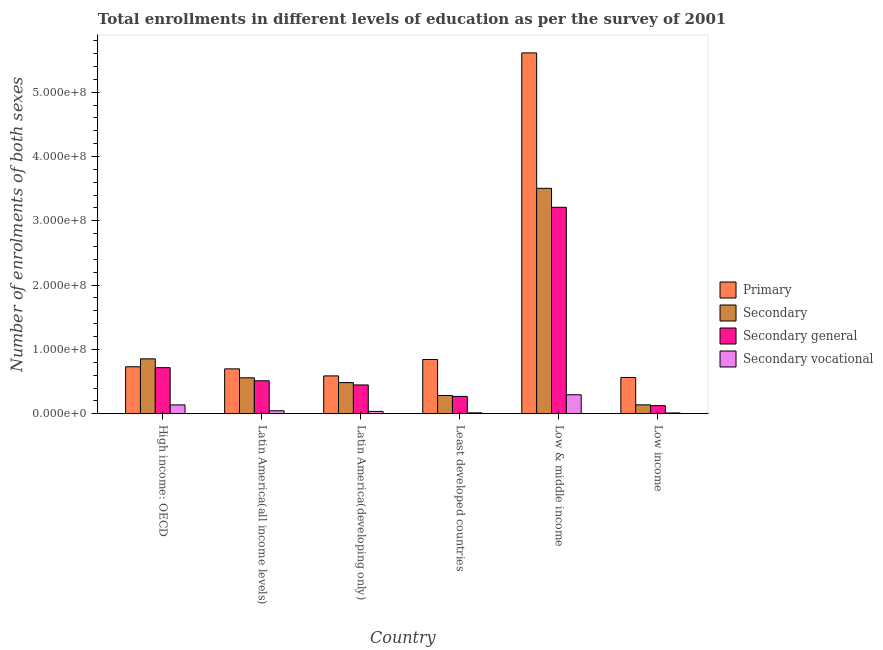How many different coloured bars are there?
Give a very brief answer. 4. How many bars are there on the 3rd tick from the left?
Your answer should be very brief. 4. What is the label of the 1st group of bars from the left?
Your answer should be compact. High income: OECD. What is the number of enrolments in secondary general education in High income: OECD?
Keep it short and to the point. 7.16e+07. Across all countries, what is the maximum number of enrolments in secondary general education?
Your response must be concise. 3.21e+08. Across all countries, what is the minimum number of enrolments in secondary general education?
Your answer should be very brief. 1.26e+07. In which country was the number of enrolments in secondary vocational education maximum?
Your response must be concise. Low & middle income. What is the total number of enrolments in secondary general education in the graph?
Offer a terse response. 5.28e+08. What is the difference between the number of enrolments in primary education in High income: OECD and that in Least developed countries?
Provide a short and direct response. -1.13e+07. What is the difference between the number of enrolments in secondary education in Latin America(developing only) and the number of enrolments in primary education in Least developed countries?
Your answer should be compact. -3.60e+07. What is the average number of enrolments in secondary general education per country?
Provide a succinct answer. 8.80e+07. What is the difference between the number of enrolments in secondary vocational education and number of enrolments in secondary education in Least developed countries?
Ensure brevity in your answer.  -2.69e+07. What is the ratio of the number of enrolments in secondary education in Latin America(all income levels) to that in Least developed countries?
Your answer should be very brief. 1.97. Is the number of enrolments in secondary education in High income: OECD less than that in Low income?
Give a very brief answer. No. What is the difference between the highest and the second highest number of enrolments in primary education?
Your answer should be very brief. 4.77e+08. What is the difference between the highest and the lowest number of enrolments in secondary vocational education?
Give a very brief answer. 2.83e+07. In how many countries, is the number of enrolments in primary education greater than the average number of enrolments in primary education taken over all countries?
Offer a very short reply. 1. Is the sum of the number of enrolments in secondary vocational education in Latin America(developing only) and Least developed countries greater than the maximum number of enrolments in secondary general education across all countries?
Make the answer very short. No. What does the 1st bar from the left in Least developed countries represents?
Give a very brief answer. Primary. What does the 3rd bar from the right in High income: OECD represents?
Offer a very short reply. Secondary. Are all the bars in the graph horizontal?
Your answer should be very brief. No. What is the difference between two consecutive major ticks on the Y-axis?
Your answer should be compact. 1.00e+08. Are the values on the major ticks of Y-axis written in scientific E-notation?
Give a very brief answer. Yes. Does the graph contain any zero values?
Offer a terse response. No. Does the graph contain grids?
Your response must be concise. No. How many legend labels are there?
Provide a succinct answer. 4. How are the legend labels stacked?
Ensure brevity in your answer.  Vertical. What is the title of the graph?
Make the answer very short. Total enrollments in different levels of education as per the survey of 2001. Does "Forest" appear as one of the legend labels in the graph?
Provide a succinct answer. No. What is the label or title of the X-axis?
Your answer should be compact. Country. What is the label or title of the Y-axis?
Provide a succinct answer. Number of enrolments of both sexes. What is the Number of enrolments of both sexes of Primary in High income: OECD?
Make the answer very short. 7.30e+07. What is the Number of enrolments of both sexes in Secondary in High income: OECD?
Offer a very short reply. 8.54e+07. What is the Number of enrolments of both sexes of Secondary general in High income: OECD?
Your answer should be compact. 7.16e+07. What is the Number of enrolments of both sexes of Secondary vocational in High income: OECD?
Your answer should be compact. 1.37e+07. What is the Number of enrolments of both sexes of Primary in Latin America(all income levels)?
Keep it short and to the point. 6.98e+07. What is the Number of enrolments of both sexes of Secondary in Latin America(all income levels)?
Offer a very short reply. 5.59e+07. What is the Number of enrolments of both sexes of Secondary general in Latin America(all income levels)?
Provide a short and direct response. 5.12e+07. What is the Number of enrolments of both sexes of Secondary vocational in Latin America(all income levels)?
Keep it short and to the point. 4.64e+06. What is the Number of enrolments of both sexes of Primary in Latin America(developing only)?
Offer a very short reply. 5.88e+07. What is the Number of enrolments of both sexes of Secondary in Latin America(developing only)?
Provide a succinct answer. 4.84e+07. What is the Number of enrolments of both sexes in Secondary general in Latin America(developing only)?
Your response must be concise. 4.48e+07. What is the Number of enrolments of both sexes in Secondary vocational in Latin America(developing only)?
Make the answer very short. 3.64e+06. What is the Number of enrolments of both sexes of Primary in Least developed countries?
Offer a very short reply. 8.44e+07. What is the Number of enrolments of both sexes of Secondary in Least developed countries?
Your answer should be compact. 2.83e+07. What is the Number of enrolments of both sexes of Secondary general in Least developed countries?
Make the answer very short. 2.69e+07. What is the Number of enrolments of both sexes in Secondary vocational in Least developed countries?
Provide a short and direct response. 1.39e+06. What is the Number of enrolments of both sexes of Primary in Low & middle income?
Make the answer very short. 5.61e+08. What is the Number of enrolments of both sexes of Secondary in Low & middle income?
Ensure brevity in your answer.  3.50e+08. What is the Number of enrolments of both sexes of Secondary general in Low & middle income?
Offer a terse response. 3.21e+08. What is the Number of enrolments of both sexes in Secondary vocational in Low & middle income?
Keep it short and to the point. 2.95e+07. What is the Number of enrolments of both sexes of Primary in Low income?
Give a very brief answer. 5.64e+07. What is the Number of enrolments of both sexes of Secondary in Low income?
Your answer should be very brief. 1.38e+07. What is the Number of enrolments of both sexes in Secondary general in Low income?
Provide a succinct answer. 1.26e+07. What is the Number of enrolments of both sexes of Secondary vocational in Low income?
Your answer should be compact. 1.23e+06. Across all countries, what is the maximum Number of enrolments of both sexes in Primary?
Your response must be concise. 5.61e+08. Across all countries, what is the maximum Number of enrolments of both sexes of Secondary?
Ensure brevity in your answer.  3.50e+08. Across all countries, what is the maximum Number of enrolments of both sexes of Secondary general?
Your answer should be very brief. 3.21e+08. Across all countries, what is the maximum Number of enrolments of both sexes in Secondary vocational?
Offer a terse response. 2.95e+07. Across all countries, what is the minimum Number of enrolments of both sexes in Primary?
Your response must be concise. 5.64e+07. Across all countries, what is the minimum Number of enrolments of both sexes of Secondary?
Offer a terse response. 1.38e+07. Across all countries, what is the minimum Number of enrolments of both sexes in Secondary general?
Provide a succinct answer. 1.26e+07. Across all countries, what is the minimum Number of enrolments of both sexes in Secondary vocational?
Your answer should be very brief. 1.23e+06. What is the total Number of enrolments of both sexes in Primary in the graph?
Provide a short and direct response. 9.03e+08. What is the total Number of enrolments of both sexes in Secondary in the graph?
Your response must be concise. 5.82e+08. What is the total Number of enrolments of both sexes of Secondary general in the graph?
Your answer should be very brief. 5.28e+08. What is the total Number of enrolments of both sexes in Secondary vocational in the graph?
Offer a terse response. 5.42e+07. What is the difference between the Number of enrolments of both sexes of Primary in High income: OECD and that in Latin America(all income levels)?
Your answer should be compact. 3.26e+06. What is the difference between the Number of enrolments of both sexes in Secondary in High income: OECD and that in Latin America(all income levels)?
Your answer should be very brief. 2.95e+07. What is the difference between the Number of enrolments of both sexes of Secondary general in High income: OECD and that in Latin America(all income levels)?
Give a very brief answer. 2.04e+07. What is the difference between the Number of enrolments of both sexes in Secondary vocational in High income: OECD and that in Latin America(all income levels)?
Provide a succinct answer. 9.10e+06. What is the difference between the Number of enrolments of both sexes in Primary in High income: OECD and that in Latin America(developing only)?
Keep it short and to the point. 1.42e+07. What is the difference between the Number of enrolments of both sexes of Secondary in High income: OECD and that in Latin America(developing only)?
Keep it short and to the point. 3.69e+07. What is the difference between the Number of enrolments of both sexes in Secondary general in High income: OECD and that in Latin America(developing only)?
Keep it short and to the point. 2.69e+07. What is the difference between the Number of enrolments of both sexes in Secondary vocational in High income: OECD and that in Latin America(developing only)?
Provide a short and direct response. 1.01e+07. What is the difference between the Number of enrolments of both sexes in Primary in High income: OECD and that in Least developed countries?
Your answer should be compact. -1.13e+07. What is the difference between the Number of enrolments of both sexes of Secondary in High income: OECD and that in Least developed countries?
Your answer should be compact. 5.70e+07. What is the difference between the Number of enrolments of both sexes in Secondary general in High income: OECD and that in Least developed countries?
Provide a succinct answer. 4.47e+07. What is the difference between the Number of enrolments of both sexes of Secondary vocational in High income: OECD and that in Least developed countries?
Give a very brief answer. 1.23e+07. What is the difference between the Number of enrolments of both sexes in Primary in High income: OECD and that in Low & middle income?
Your answer should be very brief. -4.88e+08. What is the difference between the Number of enrolments of both sexes of Secondary in High income: OECD and that in Low & middle income?
Ensure brevity in your answer.  -2.65e+08. What is the difference between the Number of enrolments of both sexes in Secondary general in High income: OECD and that in Low & middle income?
Your answer should be compact. -2.49e+08. What is the difference between the Number of enrolments of both sexes in Secondary vocational in High income: OECD and that in Low & middle income?
Provide a short and direct response. -1.58e+07. What is the difference between the Number of enrolments of both sexes in Primary in High income: OECD and that in Low income?
Your answer should be compact. 1.67e+07. What is the difference between the Number of enrolments of both sexes of Secondary in High income: OECD and that in Low income?
Keep it short and to the point. 7.15e+07. What is the difference between the Number of enrolments of both sexes of Secondary general in High income: OECD and that in Low income?
Make the answer very short. 5.90e+07. What is the difference between the Number of enrolments of both sexes in Secondary vocational in High income: OECD and that in Low income?
Give a very brief answer. 1.25e+07. What is the difference between the Number of enrolments of both sexes of Primary in Latin America(all income levels) and that in Latin America(developing only)?
Offer a terse response. 1.09e+07. What is the difference between the Number of enrolments of both sexes of Secondary in Latin America(all income levels) and that in Latin America(developing only)?
Make the answer very short. 7.45e+06. What is the difference between the Number of enrolments of both sexes of Secondary general in Latin America(all income levels) and that in Latin America(developing only)?
Provide a succinct answer. 6.46e+06. What is the difference between the Number of enrolments of both sexes in Secondary vocational in Latin America(all income levels) and that in Latin America(developing only)?
Your answer should be compact. 9.93e+05. What is the difference between the Number of enrolments of both sexes of Primary in Latin America(all income levels) and that in Least developed countries?
Your answer should be compact. -1.46e+07. What is the difference between the Number of enrolments of both sexes in Secondary in Latin America(all income levels) and that in Least developed countries?
Your answer should be compact. 2.75e+07. What is the difference between the Number of enrolments of both sexes in Secondary general in Latin America(all income levels) and that in Least developed countries?
Give a very brief answer. 2.43e+07. What is the difference between the Number of enrolments of both sexes of Secondary vocational in Latin America(all income levels) and that in Least developed countries?
Provide a short and direct response. 3.24e+06. What is the difference between the Number of enrolments of both sexes in Primary in Latin America(all income levels) and that in Low & middle income?
Give a very brief answer. -4.91e+08. What is the difference between the Number of enrolments of both sexes of Secondary in Latin America(all income levels) and that in Low & middle income?
Keep it short and to the point. -2.95e+08. What is the difference between the Number of enrolments of both sexes of Secondary general in Latin America(all income levels) and that in Low & middle income?
Make the answer very short. -2.70e+08. What is the difference between the Number of enrolments of both sexes in Secondary vocational in Latin America(all income levels) and that in Low & middle income?
Make the answer very short. -2.49e+07. What is the difference between the Number of enrolments of both sexes in Primary in Latin America(all income levels) and that in Low income?
Offer a terse response. 1.34e+07. What is the difference between the Number of enrolments of both sexes of Secondary in Latin America(all income levels) and that in Low income?
Provide a succinct answer. 4.20e+07. What is the difference between the Number of enrolments of both sexes in Secondary general in Latin America(all income levels) and that in Low income?
Offer a terse response. 3.86e+07. What is the difference between the Number of enrolments of both sexes of Secondary vocational in Latin America(all income levels) and that in Low income?
Provide a short and direct response. 3.40e+06. What is the difference between the Number of enrolments of both sexes in Primary in Latin America(developing only) and that in Least developed countries?
Your response must be concise. -2.55e+07. What is the difference between the Number of enrolments of both sexes in Secondary in Latin America(developing only) and that in Least developed countries?
Ensure brevity in your answer.  2.01e+07. What is the difference between the Number of enrolments of both sexes in Secondary general in Latin America(developing only) and that in Least developed countries?
Ensure brevity in your answer.  1.78e+07. What is the difference between the Number of enrolments of both sexes in Secondary vocational in Latin America(developing only) and that in Least developed countries?
Ensure brevity in your answer.  2.25e+06. What is the difference between the Number of enrolments of both sexes of Primary in Latin America(developing only) and that in Low & middle income?
Offer a terse response. -5.02e+08. What is the difference between the Number of enrolments of both sexes of Secondary in Latin America(developing only) and that in Low & middle income?
Ensure brevity in your answer.  -3.02e+08. What is the difference between the Number of enrolments of both sexes in Secondary general in Latin America(developing only) and that in Low & middle income?
Offer a terse response. -2.76e+08. What is the difference between the Number of enrolments of both sexes in Secondary vocational in Latin America(developing only) and that in Low & middle income?
Provide a succinct answer. -2.59e+07. What is the difference between the Number of enrolments of both sexes of Primary in Latin America(developing only) and that in Low income?
Your response must be concise. 2.46e+06. What is the difference between the Number of enrolments of both sexes in Secondary in Latin America(developing only) and that in Low income?
Provide a short and direct response. 3.46e+07. What is the difference between the Number of enrolments of both sexes of Secondary general in Latin America(developing only) and that in Low income?
Your response must be concise. 3.22e+07. What is the difference between the Number of enrolments of both sexes in Secondary vocational in Latin America(developing only) and that in Low income?
Your response must be concise. 2.41e+06. What is the difference between the Number of enrolments of both sexes of Primary in Least developed countries and that in Low & middle income?
Provide a succinct answer. -4.77e+08. What is the difference between the Number of enrolments of both sexes in Secondary in Least developed countries and that in Low & middle income?
Your answer should be very brief. -3.22e+08. What is the difference between the Number of enrolments of both sexes in Secondary general in Least developed countries and that in Low & middle income?
Offer a terse response. -2.94e+08. What is the difference between the Number of enrolments of both sexes of Secondary vocational in Least developed countries and that in Low & middle income?
Your answer should be compact. -2.81e+07. What is the difference between the Number of enrolments of both sexes in Primary in Least developed countries and that in Low income?
Your answer should be compact. 2.80e+07. What is the difference between the Number of enrolments of both sexes in Secondary in Least developed countries and that in Low income?
Offer a very short reply. 1.45e+07. What is the difference between the Number of enrolments of both sexes in Secondary general in Least developed countries and that in Low income?
Offer a very short reply. 1.44e+07. What is the difference between the Number of enrolments of both sexes of Secondary vocational in Least developed countries and that in Low income?
Keep it short and to the point. 1.60e+05. What is the difference between the Number of enrolments of both sexes of Primary in Low & middle income and that in Low income?
Provide a short and direct response. 5.05e+08. What is the difference between the Number of enrolments of both sexes in Secondary in Low & middle income and that in Low income?
Make the answer very short. 3.37e+08. What is the difference between the Number of enrolments of both sexes in Secondary general in Low & middle income and that in Low income?
Your answer should be very brief. 3.08e+08. What is the difference between the Number of enrolments of both sexes in Secondary vocational in Low & middle income and that in Low income?
Provide a succinct answer. 2.83e+07. What is the difference between the Number of enrolments of both sexes of Primary in High income: OECD and the Number of enrolments of both sexes of Secondary in Latin America(all income levels)?
Give a very brief answer. 1.72e+07. What is the difference between the Number of enrolments of both sexes of Primary in High income: OECD and the Number of enrolments of both sexes of Secondary general in Latin America(all income levels)?
Keep it short and to the point. 2.18e+07. What is the difference between the Number of enrolments of both sexes in Primary in High income: OECD and the Number of enrolments of both sexes in Secondary vocational in Latin America(all income levels)?
Your answer should be very brief. 6.84e+07. What is the difference between the Number of enrolments of both sexes of Secondary in High income: OECD and the Number of enrolments of both sexes of Secondary general in Latin America(all income levels)?
Give a very brief answer. 3.41e+07. What is the difference between the Number of enrolments of both sexes of Secondary in High income: OECD and the Number of enrolments of both sexes of Secondary vocational in Latin America(all income levels)?
Give a very brief answer. 8.07e+07. What is the difference between the Number of enrolments of both sexes in Secondary general in High income: OECD and the Number of enrolments of both sexes in Secondary vocational in Latin America(all income levels)?
Your answer should be compact. 6.70e+07. What is the difference between the Number of enrolments of both sexes of Primary in High income: OECD and the Number of enrolments of both sexes of Secondary in Latin America(developing only)?
Give a very brief answer. 2.46e+07. What is the difference between the Number of enrolments of both sexes in Primary in High income: OECD and the Number of enrolments of both sexes in Secondary general in Latin America(developing only)?
Keep it short and to the point. 2.83e+07. What is the difference between the Number of enrolments of both sexes in Primary in High income: OECD and the Number of enrolments of both sexes in Secondary vocational in Latin America(developing only)?
Offer a very short reply. 6.94e+07. What is the difference between the Number of enrolments of both sexes of Secondary in High income: OECD and the Number of enrolments of both sexes of Secondary general in Latin America(developing only)?
Keep it short and to the point. 4.06e+07. What is the difference between the Number of enrolments of both sexes in Secondary in High income: OECD and the Number of enrolments of both sexes in Secondary vocational in Latin America(developing only)?
Provide a short and direct response. 8.17e+07. What is the difference between the Number of enrolments of both sexes of Secondary general in High income: OECD and the Number of enrolments of both sexes of Secondary vocational in Latin America(developing only)?
Offer a terse response. 6.80e+07. What is the difference between the Number of enrolments of both sexes in Primary in High income: OECD and the Number of enrolments of both sexes in Secondary in Least developed countries?
Your answer should be compact. 4.47e+07. What is the difference between the Number of enrolments of both sexes of Primary in High income: OECD and the Number of enrolments of both sexes of Secondary general in Least developed countries?
Provide a succinct answer. 4.61e+07. What is the difference between the Number of enrolments of both sexes in Primary in High income: OECD and the Number of enrolments of both sexes in Secondary vocational in Least developed countries?
Offer a very short reply. 7.16e+07. What is the difference between the Number of enrolments of both sexes in Secondary in High income: OECD and the Number of enrolments of both sexes in Secondary general in Least developed countries?
Offer a very short reply. 5.84e+07. What is the difference between the Number of enrolments of both sexes of Secondary in High income: OECD and the Number of enrolments of both sexes of Secondary vocational in Least developed countries?
Give a very brief answer. 8.40e+07. What is the difference between the Number of enrolments of both sexes in Secondary general in High income: OECD and the Number of enrolments of both sexes in Secondary vocational in Least developed countries?
Provide a succinct answer. 7.02e+07. What is the difference between the Number of enrolments of both sexes of Primary in High income: OECD and the Number of enrolments of both sexes of Secondary in Low & middle income?
Your response must be concise. -2.77e+08. What is the difference between the Number of enrolments of both sexes in Primary in High income: OECD and the Number of enrolments of both sexes in Secondary general in Low & middle income?
Your answer should be compact. -2.48e+08. What is the difference between the Number of enrolments of both sexes in Primary in High income: OECD and the Number of enrolments of both sexes in Secondary vocational in Low & middle income?
Give a very brief answer. 4.35e+07. What is the difference between the Number of enrolments of both sexes in Secondary in High income: OECD and the Number of enrolments of both sexes in Secondary general in Low & middle income?
Offer a very short reply. -2.36e+08. What is the difference between the Number of enrolments of both sexes of Secondary in High income: OECD and the Number of enrolments of both sexes of Secondary vocational in Low & middle income?
Your answer should be compact. 5.58e+07. What is the difference between the Number of enrolments of both sexes in Secondary general in High income: OECD and the Number of enrolments of both sexes in Secondary vocational in Low & middle income?
Provide a succinct answer. 4.21e+07. What is the difference between the Number of enrolments of both sexes in Primary in High income: OECD and the Number of enrolments of both sexes in Secondary in Low income?
Your answer should be very brief. 5.92e+07. What is the difference between the Number of enrolments of both sexes in Primary in High income: OECD and the Number of enrolments of both sexes in Secondary general in Low income?
Your response must be concise. 6.04e+07. What is the difference between the Number of enrolments of both sexes of Primary in High income: OECD and the Number of enrolments of both sexes of Secondary vocational in Low income?
Offer a terse response. 7.18e+07. What is the difference between the Number of enrolments of both sexes of Secondary in High income: OECD and the Number of enrolments of both sexes of Secondary general in Low income?
Keep it short and to the point. 7.28e+07. What is the difference between the Number of enrolments of both sexes in Secondary in High income: OECD and the Number of enrolments of both sexes in Secondary vocational in Low income?
Keep it short and to the point. 8.41e+07. What is the difference between the Number of enrolments of both sexes of Secondary general in High income: OECD and the Number of enrolments of both sexes of Secondary vocational in Low income?
Give a very brief answer. 7.04e+07. What is the difference between the Number of enrolments of both sexes in Primary in Latin America(all income levels) and the Number of enrolments of both sexes in Secondary in Latin America(developing only)?
Provide a succinct answer. 2.14e+07. What is the difference between the Number of enrolments of both sexes in Primary in Latin America(all income levels) and the Number of enrolments of both sexes in Secondary general in Latin America(developing only)?
Make the answer very short. 2.50e+07. What is the difference between the Number of enrolments of both sexes in Primary in Latin America(all income levels) and the Number of enrolments of both sexes in Secondary vocational in Latin America(developing only)?
Your answer should be very brief. 6.61e+07. What is the difference between the Number of enrolments of both sexes in Secondary in Latin America(all income levels) and the Number of enrolments of both sexes in Secondary general in Latin America(developing only)?
Ensure brevity in your answer.  1.11e+07. What is the difference between the Number of enrolments of both sexes of Secondary in Latin America(all income levels) and the Number of enrolments of both sexes of Secondary vocational in Latin America(developing only)?
Keep it short and to the point. 5.22e+07. What is the difference between the Number of enrolments of both sexes in Secondary general in Latin America(all income levels) and the Number of enrolments of both sexes in Secondary vocational in Latin America(developing only)?
Your answer should be very brief. 4.76e+07. What is the difference between the Number of enrolments of both sexes in Primary in Latin America(all income levels) and the Number of enrolments of both sexes in Secondary in Least developed countries?
Your answer should be compact. 4.14e+07. What is the difference between the Number of enrolments of both sexes in Primary in Latin America(all income levels) and the Number of enrolments of both sexes in Secondary general in Least developed countries?
Ensure brevity in your answer.  4.28e+07. What is the difference between the Number of enrolments of both sexes of Primary in Latin America(all income levels) and the Number of enrolments of both sexes of Secondary vocational in Least developed countries?
Provide a succinct answer. 6.84e+07. What is the difference between the Number of enrolments of both sexes of Secondary in Latin America(all income levels) and the Number of enrolments of both sexes of Secondary general in Least developed countries?
Your response must be concise. 2.89e+07. What is the difference between the Number of enrolments of both sexes in Secondary in Latin America(all income levels) and the Number of enrolments of both sexes in Secondary vocational in Least developed countries?
Your answer should be very brief. 5.45e+07. What is the difference between the Number of enrolments of both sexes of Secondary general in Latin America(all income levels) and the Number of enrolments of both sexes of Secondary vocational in Least developed countries?
Offer a terse response. 4.98e+07. What is the difference between the Number of enrolments of both sexes in Primary in Latin America(all income levels) and the Number of enrolments of both sexes in Secondary in Low & middle income?
Your response must be concise. -2.81e+08. What is the difference between the Number of enrolments of both sexes of Primary in Latin America(all income levels) and the Number of enrolments of both sexes of Secondary general in Low & middle income?
Offer a very short reply. -2.51e+08. What is the difference between the Number of enrolments of both sexes in Primary in Latin America(all income levels) and the Number of enrolments of both sexes in Secondary vocational in Low & middle income?
Ensure brevity in your answer.  4.02e+07. What is the difference between the Number of enrolments of both sexes in Secondary in Latin America(all income levels) and the Number of enrolments of both sexes in Secondary general in Low & middle income?
Your answer should be very brief. -2.65e+08. What is the difference between the Number of enrolments of both sexes in Secondary in Latin America(all income levels) and the Number of enrolments of both sexes in Secondary vocational in Low & middle income?
Your answer should be very brief. 2.63e+07. What is the difference between the Number of enrolments of both sexes in Secondary general in Latin America(all income levels) and the Number of enrolments of both sexes in Secondary vocational in Low & middle income?
Make the answer very short. 2.17e+07. What is the difference between the Number of enrolments of both sexes of Primary in Latin America(all income levels) and the Number of enrolments of both sexes of Secondary in Low income?
Offer a terse response. 5.59e+07. What is the difference between the Number of enrolments of both sexes of Primary in Latin America(all income levels) and the Number of enrolments of both sexes of Secondary general in Low income?
Your answer should be compact. 5.72e+07. What is the difference between the Number of enrolments of both sexes in Primary in Latin America(all income levels) and the Number of enrolments of both sexes in Secondary vocational in Low income?
Offer a terse response. 6.85e+07. What is the difference between the Number of enrolments of both sexes of Secondary in Latin America(all income levels) and the Number of enrolments of both sexes of Secondary general in Low income?
Your answer should be compact. 4.33e+07. What is the difference between the Number of enrolments of both sexes in Secondary in Latin America(all income levels) and the Number of enrolments of both sexes in Secondary vocational in Low income?
Your answer should be compact. 5.46e+07. What is the difference between the Number of enrolments of both sexes of Secondary general in Latin America(all income levels) and the Number of enrolments of both sexes of Secondary vocational in Low income?
Keep it short and to the point. 5.00e+07. What is the difference between the Number of enrolments of both sexes in Primary in Latin America(developing only) and the Number of enrolments of both sexes in Secondary in Least developed countries?
Ensure brevity in your answer.  3.05e+07. What is the difference between the Number of enrolments of both sexes in Primary in Latin America(developing only) and the Number of enrolments of both sexes in Secondary general in Least developed countries?
Make the answer very short. 3.19e+07. What is the difference between the Number of enrolments of both sexes in Primary in Latin America(developing only) and the Number of enrolments of both sexes in Secondary vocational in Least developed countries?
Your answer should be very brief. 5.74e+07. What is the difference between the Number of enrolments of both sexes of Secondary in Latin America(developing only) and the Number of enrolments of both sexes of Secondary general in Least developed countries?
Ensure brevity in your answer.  2.15e+07. What is the difference between the Number of enrolments of both sexes in Secondary in Latin America(developing only) and the Number of enrolments of both sexes in Secondary vocational in Least developed countries?
Offer a terse response. 4.70e+07. What is the difference between the Number of enrolments of both sexes in Secondary general in Latin America(developing only) and the Number of enrolments of both sexes in Secondary vocational in Least developed countries?
Offer a very short reply. 4.34e+07. What is the difference between the Number of enrolments of both sexes of Primary in Latin America(developing only) and the Number of enrolments of both sexes of Secondary in Low & middle income?
Your response must be concise. -2.92e+08. What is the difference between the Number of enrolments of both sexes in Primary in Latin America(developing only) and the Number of enrolments of both sexes in Secondary general in Low & middle income?
Your answer should be very brief. -2.62e+08. What is the difference between the Number of enrolments of both sexes of Primary in Latin America(developing only) and the Number of enrolments of both sexes of Secondary vocational in Low & middle income?
Your response must be concise. 2.93e+07. What is the difference between the Number of enrolments of both sexes of Secondary in Latin America(developing only) and the Number of enrolments of both sexes of Secondary general in Low & middle income?
Make the answer very short. -2.73e+08. What is the difference between the Number of enrolments of both sexes in Secondary in Latin America(developing only) and the Number of enrolments of both sexes in Secondary vocational in Low & middle income?
Ensure brevity in your answer.  1.89e+07. What is the difference between the Number of enrolments of both sexes in Secondary general in Latin America(developing only) and the Number of enrolments of both sexes in Secondary vocational in Low & middle income?
Provide a succinct answer. 1.52e+07. What is the difference between the Number of enrolments of both sexes in Primary in Latin America(developing only) and the Number of enrolments of both sexes in Secondary in Low income?
Offer a terse response. 4.50e+07. What is the difference between the Number of enrolments of both sexes of Primary in Latin America(developing only) and the Number of enrolments of both sexes of Secondary general in Low income?
Offer a terse response. 4.62e+07. What is the difference between the Number of enrolments of both sexes in Primary in Latin America(developing only) and the Number of enrolments of both sexes in Secondary vocational in Low income?
Provide a short and direct response. 5.76e+07. What is the difference between the Number of enrolments of both sexes in Secondary in Latin America(developing only) and the Number of enrolments of both sexes in Secondary general in Low income?
Make the answer very short. 3.58e+07. What is the difference between the Number of enrolments of both sexes in Secondary in Latin America(developing only) and the Number of enrolments of both sexes in Secondary vocational in Low income?
Keep it short and to the point. 4.72e+07. What is the difference between the Number of enrolments of both sexes in Secondary general in Latin America(developing only) and the Number of enrolments of both sexes in Secondary vocational in Low income?
Your answer should be compact. 4.35e+07. What is the difference between the Number of enrolments of both sexes in Primary in Least developed countries and the Number of enrolments of both sexes in Secondary in Low & middle income?
Make the answer very short. -2.66e+08. What is the difference between the Number of enrolments of both sexes of Primary in Least developed countries and the Number of enrolments of both sexes of Secondary general in Low & middle income?
Keep it short and to the point. -2.37e+08. What is the difference between the Number of enrolments of both sexes in Primary in Least developed countries and the Number of enrolments of both sexes in Secondary vocational in Low & middle income?
Make the answer very short. 5.48e+07. What is the difference between the Number of enrolments of both sexes of Secondary in Least developed countries and the Number of enrolments of both sexes of Secondary general in Low & middle income?
Your response must be concise. -2.93e+08. What is the difference between the Number of enrolments of both sexes of Secondary in Least developed countries and the Number of enrolments of both sexes of Secondary vocational in Low & middle income?
Make the answer very short. -1.18e+06. What is the difference between the Number of enrolments of both sexes of Secondary general in Least developed countries and the Number of enrolments of both sexes of Secondary vocational in Low & middle income?
Your answer should be compact. -2.57e+06. What is the difference between the Number of enrolments of both sexes in Primary in Least developed countries and the Number of enrolments of both sexes in Secondary in Low income?
Make the answer very short. 7.05e+07. What is the difference between the Number of enrolments of both sexes of Primary in Least developed countries and the Number of enrolments of both sexes of Secondary general in Low income?
Keep it short and to the point. 7.18e+07. What is the difference between the Number of enrolments of both sexes in Primary in Least developed countries and the Number of enrolments of both sexes in Secondary vocational in Low income?
Give a very brief answer. 8.31e+07. What is the difference between the Number of enrolments of both sexes in Secondary in Least developed countries and the Number of enrolments of both sexes in Secondary general in Low income?
Your answer should be compact. 1.57e+07. What is the difference between the Number of enrolments of both sexes in Secondary in Least developed countries and the Number of enrolments of both sexes in Secondary vocational in Low income?
Provide a short and direct response. 2.71e+07. What is the difference between the Number of enrolments of both sexes of Secondary general in Least developed countries and the Number of enrolments of both sexes of Secondary vocational in Low income?
Make the answer very short. 2.57e+07. What is the difference between the Number of enrolments of both sexes of Primary in Low & middle income and the Number of enrolments of both sexes of Secondary in Low income?
Make the answer very short. 5.47e+08. What is the difference between the Number of enrolments of both sexes in Primary in Low & middle income and the Number of enrolments of both sexes in Secondary general in Low income?
Offer a very short reply. 5.48e+08. What is the difference between the Number of enrolments of both sexes of Primary in Low & middle income and the Number of enrolments of both sexes of Secondary vocational in Low income?
Keep it short and to the point. 5.60e+08. What is the difference between the Number of enrolments of both sexes in Secondary in Low & middle income and the Number of enrolments of both sexes in Secondary general in Low income?
Give a very brief answer. 3.38e+08. What is the difference between the Number of enrolments of both sexes in Secondary in Low & middle income and the Number of enrolments of both sexes in Secondary vocational in Low income?
Make the answer very short. 3.49e+08. What is the difference between the Number of enrolments of both sexes in Secondary general in Low & middle income and the Number of enrolments of both sexes in Secondary vocational in Low income?
Make the answer very short. 3.20e+08. What is the average Number of enrolments of both sexes of Primary per country?
Make the answer very short. 1.51e+08. What is the average Number of enrolments of both sexes in Secondary per country?
Make the answer very short. 9.70e+07. What is the average Number of enrolments of both sexes of Secondary general per country?
Keep it short and to the point. 8.80e+07. What is the average Number of enrolments of both sexes of Secondary vocational per country?
Offer a terse response. 9.03e+06. What is the difference between the Number of enrolments of both sexes in Primary and Number of enrolments of both sexes in Secondary in High income: OECD?
Provide a short and direct response. -1.23e+07. What is the difference between the Number of enrolments of both sexes of Primary and Number of enrolments of both sexes of Secondary general in High income: OECD?
Ensure brevity in your answer.  1.41e+06. What is the difference between the Number of enrolments of both sexes of Primary and Number of enrolments of both sexes of Secondary vocational in High income: OECD?
Your response must be concise. 5.93e+07. What is the difference between the Number of enrolments of both sexes of Secondary and Number of enrolments of both sexes of Secondary general in High income: OECD?
Offer a terse response. 1.37e+07. What is the difference between the Number of enrolments of both sexes of Secondary and Number of enrolments of both sexes of Secondary vocational in High income: OECD?
Ensure brevity in your answer.  7.16e+07. What is the difference between the Number of enrolments of both sexes in Secondary general and Number of enrolments of both sexes in Secondary vocational in High income: OECD?
Give a very brief answer. 5.79e+07. What is the difference between the Number of enrolments of both sexes in Primary and Number of enrolments of both sexes in Secondary in Latin America(all income levels)?
Make the answer very short. 1.39e+07. What is the difference between the Number of enrolments of both sexes of Primary and Number of enrolments of both sexes of Secondary general in Latin America(all income levels)?
Give a very brief answer. 1.85e+07. What is the difference between the Number of enrolments of both sexes in Primary and Number of enrolments of both sexes in Secondary vocational in Latin America(all income levels)?
Offer a terse response. 6.51e+07. What is the difference between the Number of enrolments of both sexes of Secondary and Number of enrolments of both sexes of Secondary general in Latin America(all income levels)?
Offer a very short reply. 4.64e+06. What is the difference between the Number of enrolments of both sexes of Secondary and Number of enrolments of both sexes of Secondary vocational in Latin America(all income levels)?
Provide a short and direct response. 5.12e+07. What is the difference between the Number of enrolments of both sexes of Secondary general and Number of enrolments of both sexes of Secondary vocational in Latin America(all income levels)?
Ensure brevity in your answer.  4.66e+07. What is the difference between the Number of enrolments of both sexes of Primary and Number of enrolments of both sexes of Secondary in Latin America(developing only)?
Your answer should be very brief. 1.04e+07. What is the difference between the Number of enrolments of both sexes of Primary and Number of enrolments of both sexes of Secondary general in Latin America(developing only)?
Ensure brevity in your answer.  1.41e+07. What is the difference between the Number of enrolments of both sexes of Primary and Number of enrolments of both sexes of Secondary vocational in Latin America(developing only)?
Offer a terse response. 5.52e+07. What is the difference between the Number of enrolments of both sexes in Secondary and Number of enrolments of both sexes in Secondary general in Latin America(developing only)?
Make the answer very short. 3.64e+06. What is the difference between the Number of enrolments of both sexes of Secondary and Number of enrolments of both sexes of Secondary vocational in Latin America(developing only)?
Ensure brevity in your answer.  4.48e+07. What is the difference between the Number of enrolments of both sexes of Secondary general and Number of enrolments of both sexes of Secondary vocational in Latin America(developing only)?
Keep it short and to the point. 4.11e+07. What is the difference between the Number of enrolments of both sexes of Primary and Number of enrolments of both sexes of Secondary in Least developed countries?
Keep it short and to the point. 5.60e+07. What is the difference between the Number of enrolments of both sexes in Primary and Number of enrolments of both sexes in Secondary general in Least developed countries?
Give a very brief answer. 5.74e+07. What is the difference between the Number of enrolments of both sexes in Primary and Number of enrolments of both sexes in Secondary vocational in Least developed countries?
Your answer should be very brief. 8.30e+07. What is the difference between the Number of enrolments of both sexes in Secondary and Number of enrolments of both sexes in Secondary general in Least developed countries?
Keep it short and to the point. 1.39e+06. What is the difference between the Number of enrolments of both sexes in Secondary and Number of enrolments of both sexes in Secondary vocational in Least developed countries?
Make the answer very short. 2.69e+07. What is the difference between the Number of enrolments of both sexes in Secondary general and Number of enrolments of both sexes in Secondary vocational in Least developed countries?
Offer a very short reply. 2.56e+07. What is the difference between the Number of enrolments of both sexes of Primary and Number of enrolments of both sexes of Secondary in Low & middle income?
Make the answer very short. 2.11e+08. What is the difference between the Number of enrolments of both sexes in Primary and Number of enrolments of both sexes in Secondary general in Low & middle income?
Give a very brief answer. 2.40e+08. What is the difference between the Number of enrolments of both sexes of Primary and Number of enrolments of both sexes of Secondary vocational in Low & middle income?
Provide a succinct answer. 5.31e+08. What is the difference between the Number of enrolments of both sexes in Secondary and Number of enrolments of both sexes in Secondary general in Low & middle income?
Ensure brevity in your answer.  2.95e+07. What is the difference between the Number of enrolments of both sexes of Secondary and Number of enrolments of both sexes of Secondary vocational in Low & middle income?
Make the answer very short. 3.21e+08. What is the difference between the Number of enrolments of both sexes of Secondary general and Number of enrolments of both sexes of Secondary vocational in Low & middle income?
Your answer should be compact. 2.91e+08. What is the difference between the Number of enrolments of both sexes in Primary and Number of enrolments of both sexes in Secondary in Low income?
Your answer should be very brief. 4.25e+07. What is the difference between the Number of enrolments of both sexes of Primary and Number of enrolments of both sexes of Secondary general in Low income?
Keep it short and to the point. 4.38e+07. What is the difference between the Number of enrolments of both sexes of Primary and Number of enrolments of both sexes of Secondary vocational in Low income?
Keep it short and to the point. 5.51e+07. What is the difference between the Number of enrolments of both sexes of Secondary and Number of enrolments of both sexes of Secondary general in Low income?
Offer a very short reply. 1.23e+06. What is the difference between the Number of enrolments of both sexes in Secondary and Number of enrolments of both sexes in Secondary vocational in Low income?
Give a very brief answer. 1.26e+07. What is the difference between the Number of enrolments of both sexes of Secondary general and Number of enrolments of both sexes of Secondary vocational in Low income?
Provide a short and direct response. 1.14e+07. What is the ratio of the Number of enrolments of both sexes in Primary in High income: OECD to that in Latin America(all income levels)?
Your answer should be compact. 1.05. What is the ratio of the Number of enrolments of both sexes in Secondary in High income: OECD to that in Latin America(all income levels)?
Give a very brief answer. 1.53. What is the ratio of the Number of enrolments of both sexes in Secondary general in High income: OECD to that in Latin America(all income levels)?
Offer a terse response. 1.4. What is the ratio of the Number of enrolments of both sexes of Secondary vocational in High income: OECD to that in Latin America(all income levels)?
Provide a short and direct response. 2.96. What is the ratio of the Number of enrolments of both sexes of Primary in High income: OECD to that in Latin America(developing only)?
Your answer should be compact. 1.24. What is the ratio of the Number of enrolments of both sexes in Secondary in High income: OECD to that in Latin America(developing only)?
Offer a terse response. 1.76. What is the ratio of the Number of enrolments of both sexes in Secondary general in High income: OECD to that in Latin America(developing only)?
Give a very brief answer. 1.6. What is the ratio of the Number of enrolments of both sexes of Secondary vocational in High income: OECD to that in Latin America(developing only)?
Offer a very short reply. 3.77. What is the ratio of the Number of enrolments of both sexes of Primary in High income: OECD to that in Least developed countries?
Your answer should be compact. 0.87. What is the ratio of the Number of enrolments of both sexes in Secondary in High income: OECD to that in Least developed countries?
Offer a terse response. 3.01. What is the ratio of the Number of enrolments of both sexes of Secondary general in High income: OECD to that in Least developed countries?
Ensure brevity in your answer.  2.66. What is the ratio of the Number of enrolments of both sexes of Secondary vocational in High income: OECD to that in Least developed countries?
Give a very brief answer. 9.87. What is the ratio of the Number of enrolments of both sexes of Primary in High income: OECD to that in Low & middle income?
Ensure brevity in your answer.  0.13. What is the ratio of the Number of enrolments of both sexes of Secondary in High income: OECD to that in Low & middle income?
Offer a terse response. 0.24. What is the ratio of the Number of enrolments of both sexes in Secondary general in High income: OECD to that in Low & middle income?
Keep it short and to the point. 0.22. What is the ratio of the Number of enrolments of both sexes of Secondary vocational in High income: OECD to that in Low & middle income?
Your answer should be compact. 0.47. What is the ratio of the Number of enrolments of both sexes of Primary in High income: OECD to that in Low income?
Provide a short and direct response. 1.3. What is the ratio of the Number of enrolments of both sexes in Secondary in High income: OECD to that in Low income?
Your response must be concise. 6.17. What is the ratio of the Number of enrolments of both sexes in Secondary general in High income: OECD to that in Low income?
Your response must be concise. 5.69. What is the ratio of the Number of enrolments of both sexes in Secondary vocational in High income: OECD to that in Low income?
Your response must be concise. 11.15. What is the ratio of the Number of enrolments of both sexes of Primary in Latin America(all income levels) to that in Latin America(developing only)?
Your answer should be compact. 1.19. What is the ratio of the Number of enrolments of both sexes of Secondary in Latin America(all income levels) to that in Latin America(developing only)?
Keep it short and to the point. 1.15. What is the ratio of the Number of enrolments of both sexes of Secondary general in Latin America(all income levels) to that in Latin America(developing only)?
Offer a terse response. 1.14. What is the ratio of the Number of enrolments of both sexes in Secondary vocational in Latin America(all income levels) to that in Latin America(developing only)?
Offer a terse response. 1.27. What is the ratio of the Number of enrolments of both sexes in Primary in Latin America(all income levels) to that in Least developed countries?
Offer a very short reply. 0.83. What is the ratio of the Number of enrolments of both sexes in Secondary in Latin America(all income levels) to that in Least developed countries?
Provide a short and direct response. 1.97. What is the ratio of the Number of enrolments of both sexes in Secondary general in Latin America(all income levels) to that in Least developed countries?
Give a very brief answer. 1.9. What is the ratio of the Number of enrolments of both sexes of Secondary vocational in Latin America(all income levels) to that in Least developed countries?
Make the answer very short. 3.33. What is the ratio of the Number of enrolments of both sexes in Primary in Latin America(all income levels) to that in Low & middle income?
Keep it short and to the point. 0.12. What is the ratio of the Number of enrolments of both sexes of Secondary in Latin America(all income levels) to that in Low & middle income?
Your response must be concise. 0.16. What is the ratio of the Number of enrolments of both sexes of Secondary general in Latin America(all income levels) to that in Low & middle income?
Your response must be concise. 0.16. What is the ratio of the Number of enrolments of both sexes in Secondary vocational in Latin America(all income levels) to that in Low & middle income?
Provide a short and direct response. 0.16. What is the ratio of the Number of enrolments of both sexes of Primary in Latin America(all income levels) to that in Low income?
Make the answer very short. 1.24. What is the ratio of the Number of enrolments of both sexes of Secondary in Latin America(all income levels) to that in Low income?
Ensure brevity in your answer.  4.04. What is the ratio of the Number of enrolments of both sexes of Secondary general in Latin America(all income levels) to that in Low income?
Your answer should be very brief. 4.07. What is the ratio of the Number of enrolments of both sexes of Secondary vocational in Latin America(all income levels) to that in Low income?
Provide a succinct answer. 3.76. What is the ratio of the Number of enrolments of both sexes of Primary in Latin America(developing only) to that in Least developed countries?
Your answer should be very brief. 0.7. What is the ratio of the Number of enrolments of both sexes in Secondary in Latin America(developing only) to that in Least developed countries?
Offer a very short reply. 1.71. What is the ratio of the Number of enrolments of both sexes of Secondary general in Latin America(developing only) to that in Least developed countries?
Offer a terse response. 1.66. What is the ratio of the Number of enrolments of both sexes of Secondary vocational in Latin America(developing only) to that in Least developed countries?
Give a very brief answer. 2.62. What is the ratio of the Number of enrolments of both sexes of Primary in Latin America(developing only) to that in Low & middle income?
Give a very brief answer. 0.1. What is the ratio of the Number of enrolments of both sexes of Secondary in Latin America(developing only) to that in Low & middle income?
Keep it short and to the point. 0.14. What is the ratio of the Number of enrolments of both sexes of Secondary general in Latin America(developing only) to that in Low & middle income?
Your answer should be compact. 0.14. What is the ratio of the Number of enrolments of both sexes in Secondary vocational in Latin America(developing only) to that in Low & middle income?
Provide a short and direct response. 0.12. What is the ratio of the Number of enrolments of both sexes of Primary in Latin America(developing only) to that in Low income?
Offer a very short reply. 1.04. What is the ratio of the Number of enrolments of both sexes of Secondary in Latin America(developing only) to that in Low income?
Your answer should be very brief. 3.5. What is the ratio of the Number of enrolments of both sexes of Secondary general in Latin America(developing only) to that in Low income?
Your answer should be very brief. 3.55. What is the ratio of the Number of enrolments of both sexes in Secondary vocational in Latin America(developing only) to that in Low income?
Ensure brevity in your answer.  2.96. What is the ratio of the Number of enrolments of both sexes of Primary in Least developed countries to that in Low & middle income?
Offer a terse response. 0.15. What is the ratio of the Number of enrolments of both sexes of Secondary in Least developed countries to that in Low & middle income?
Offer a terse response. 0.08. What is the ratio of the Number of enrolments of both sexes of Secondary general in Least developed countries to that in Low & middle income?
Give a very brief answer. 0.08. What is the ratio of the Number of enrolments of both sexes of Secondary vocational in Least developed countries to that in Low & middle income?
Make the answer very short. 0.05. What is the ratio of the Number of enrolments of both sexes in Primary in Least developed countries to that in Low income?
Provide a succinct answer. 1.5. What is the ratio of the Number of enrolments of both sexes in Secondary in Least developed countries to that in Low income?
Provide a succinct answer. 2.05. What is the ratio of the Number of enrolments of both sexes in Secondary general in Least developed countries to that in Low income?
Give a very brief answer. 2.14. What is the ratio of the Number of enrolments of both sexes in Secondary vocational in Least developed countries to that in Low income?
Your answer should be very brief. 1.13. What is the ratio of the Number of enrolments of both sexes in Primary in Low & middle income to that in Low income?
Provide a short and direct response. 9.95. What is the ratio of the Number of enrolments of both sexes in Secondary in Low & middle income to that in Low income?
Give a very brief answer. 25.35. What is the ratio of the Number of enrolments of both sexes in Secondary general in Low & middle income to that in Low income?
Offer a very short reply. 25.48. What is the ratio of the Number of enrolments of both sexes of Secondary vocational in Low & middle income to that in Low income?
Ensure brevity in your answer.  23.97. What is the difference between the highest and the second highest Number of enrolments of both sexes of Primary?
Your answer should be very brief. 4.77e+08. What is the difference between the highest and the second highest Number of enrolments of both sexes of Secondary?
Offer a terse response. 2.65e+08. What is the difference between the highest and the second highest Number of enrolments of both sexes of Secondary general?
Offer a very short reply. 2.49e+08. What is the difference between the highest and the second highest Number of enrolments of both sexes of Secondary vocational?
Ensure brevity in your answer.  1.58e+07. What is the difference between the highest and the lowest Number of enrolments of both sexes in Primary?
Offer a terse response. 5.05e+08. What is the difference between the highest and the lowest Number of enrolments of both sexes of Secondary?
Ensure brevity in your answer.  3.37e+08. What is the difference between the highest and the lowest Number of enrolments of both sexes in Secondary general?
Your answer should be compact. 3.08e+08. What is the difference between the highest and the lowest Number of enrolments of both sexes in Secondary vocational?
Your answer should be very brief. 2.83e+07. 